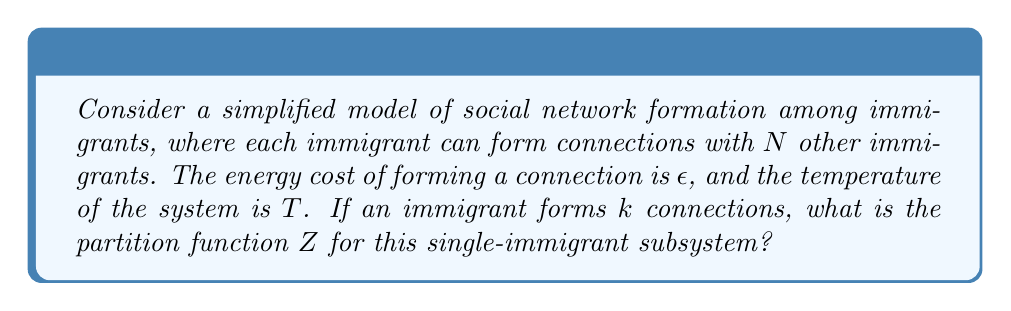Could you help me with this problem? To solve this problem, we'll follow these steps:

1) In statistical mechanics, the partition function $Z$ is the sum of Boltzmann factors over all possible states of the system.

2) In this case, an immigrant can form 0 to $N$ connections. Each state corresponds to a number of connections $k$.

3) The energy of a state with $k$ connections is $E_k = k\epsilon$.

4) The Boltzmann factor for a state with energy $E$ is $e^{-E/(k_B T)}$, where $k_B$ is the Boltzmann constant.

5) Therefore, the partition function is:

   $$Z = \sum_{k=0}^N e^{-k\epsilon/(k_B T)}$$

6) This is a geometric series with $N+1$ terms. The first term (for $k=0$) is 1, and the common ratio is $e^{-\epsilon/(k_B T)}$.

7) The sum of a geometric series with first term $a$, common ratio $r$, and $n$ terms is given by:

   $$S_n = a\frac{1-r^n}{1-r}$$

8) In our case, $a=1$, $r=e^{-\epsilon/(k_B T)}$, and $n=N+1$.

9) Applying this formula, we get:

   $$Z = \frac{1-e^{-(N+1)\epsilon/(k_B T)}}{1-e^{-\epsilon/(k_B T)}}$$

This is the partition function for the single-immigrant subsystem.
Answer: $$Z = \frac{1-e^{-(N+1)\epsilon/(k_B T)}}{1-e^{-\epsilon/(k_B T)}}$$ 